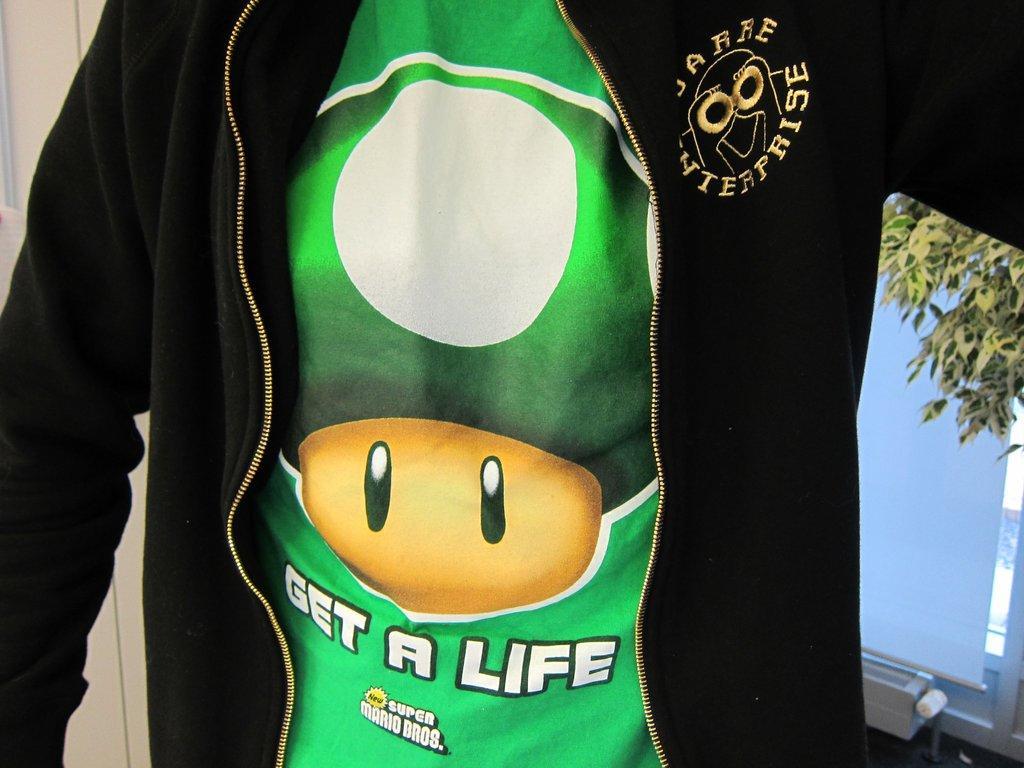How would you summarize this image in a sentence or two? In this picture we can see a t-shirt, black jacket and in the background we can see leaves and some objects. 